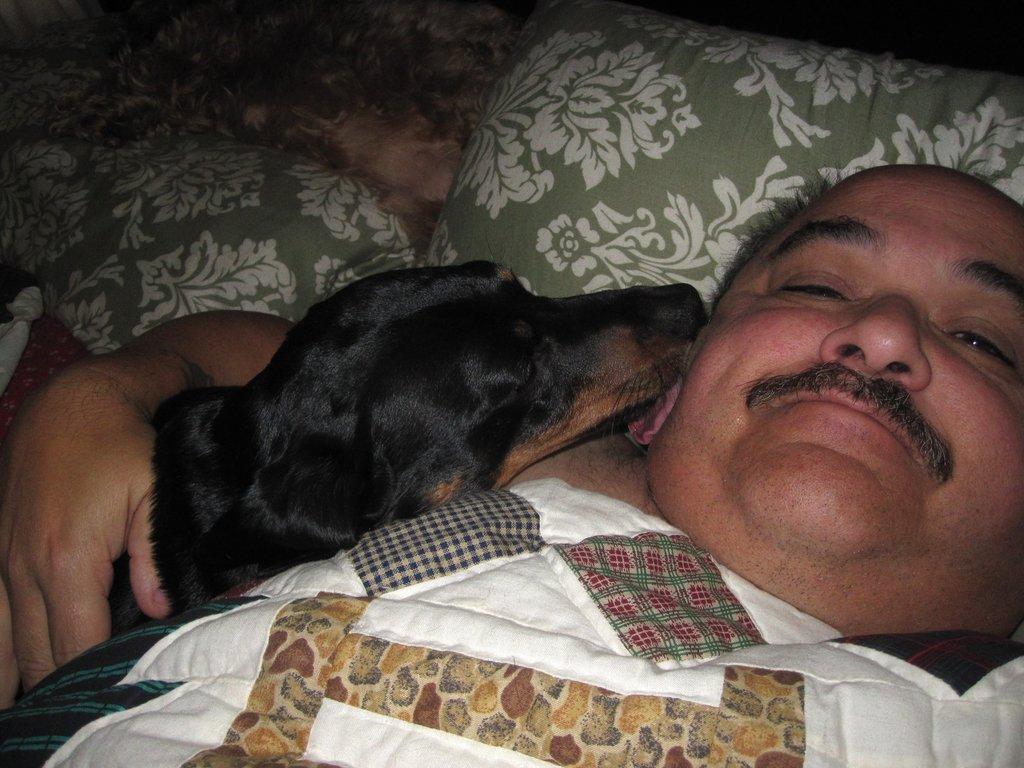In one or two sentences, can you explain what this image depicts? The image is inside the room. In the image there is a man lying on bed and also holding a dog on his hand, in background we can see pillow. 